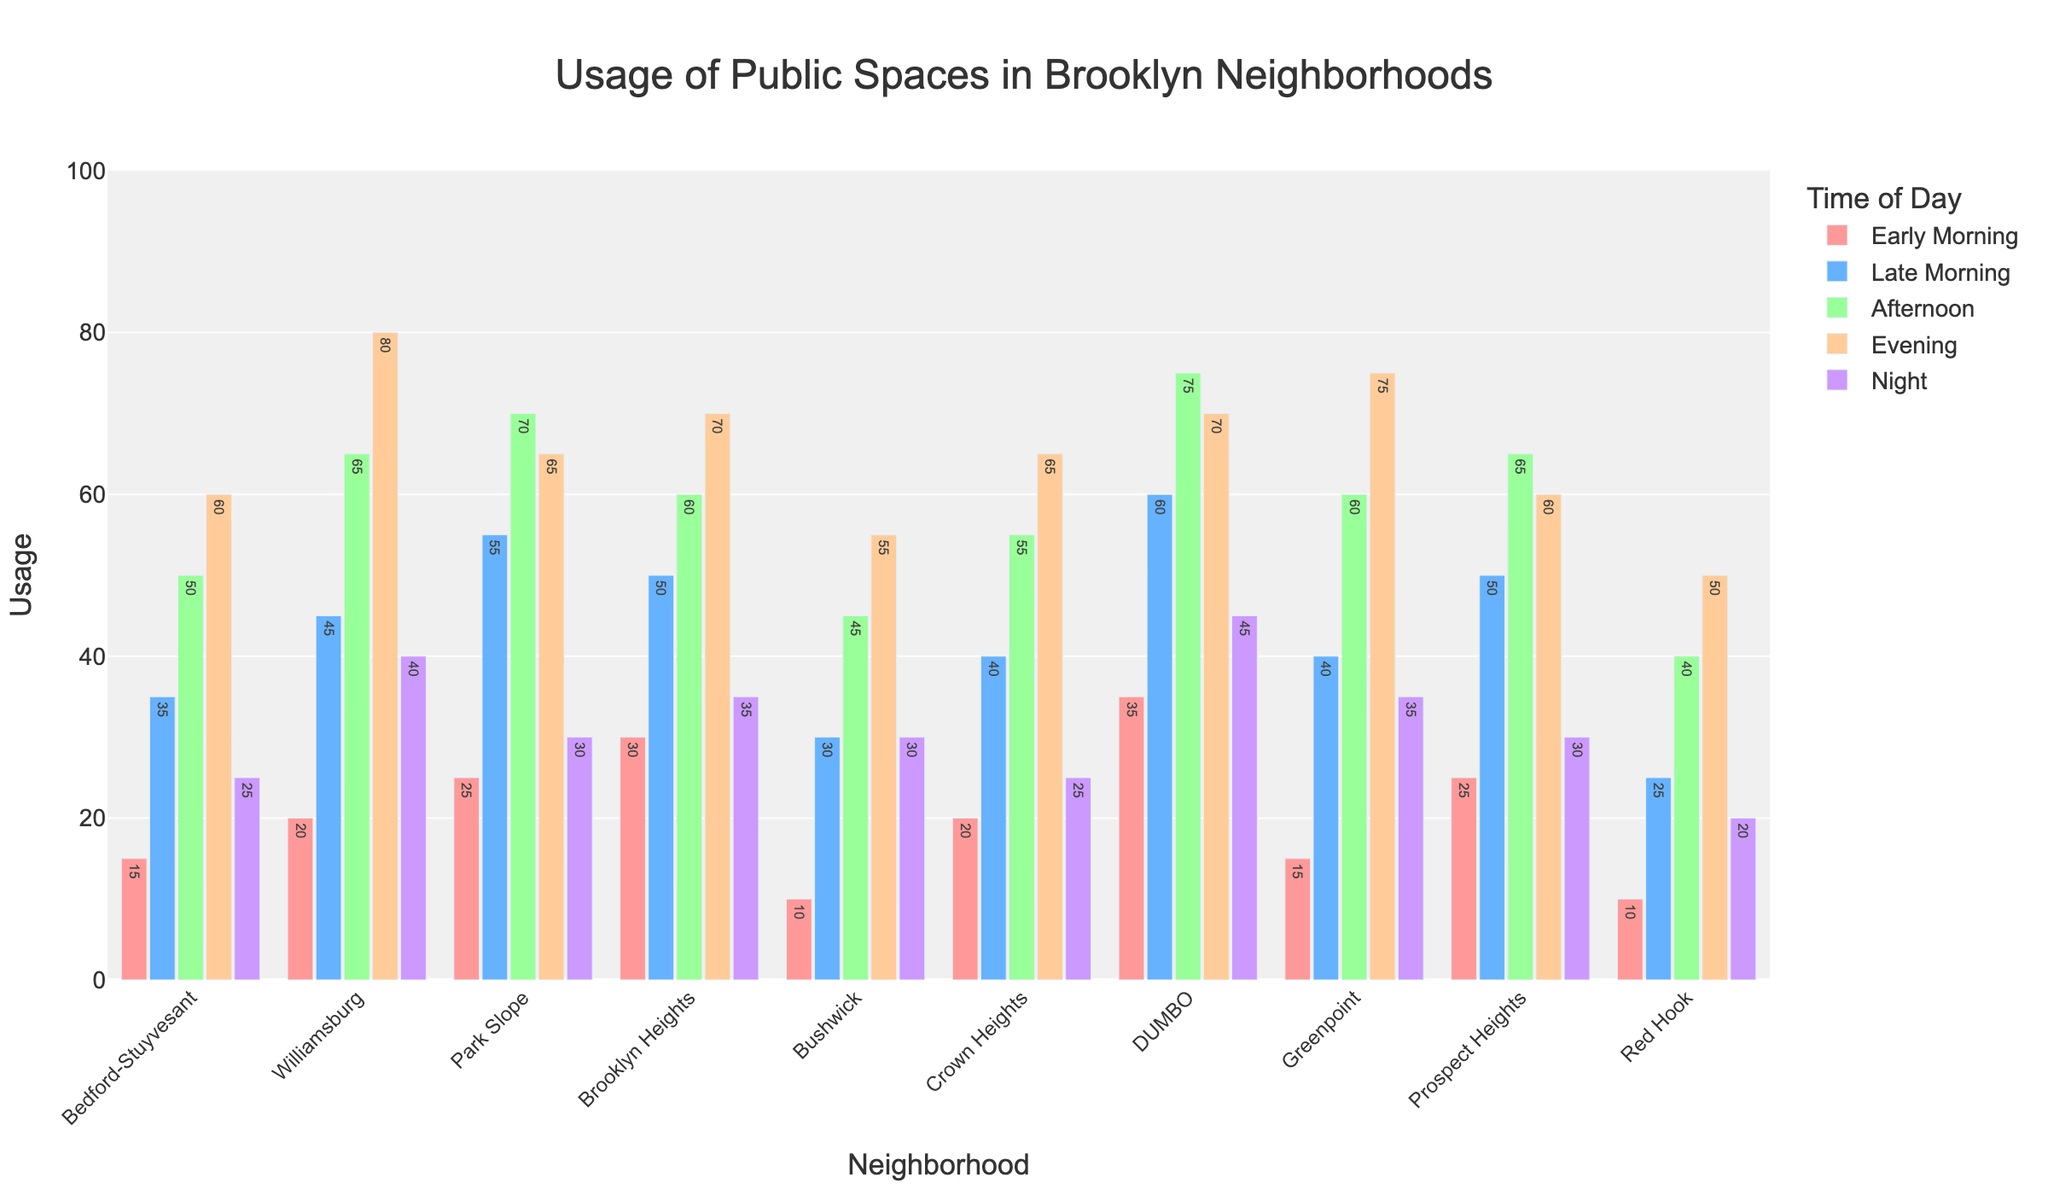Which neighborhood has the highest usage of public spaces in the early morning? To find the answer, look at the bar heights for "Early Morning" and identify the tallest one. The tallest bar in the "Early Morning" category belongs to DUMBO.
Answer: DUMBO Which time period has the highest usage in Williamsburg? For Williamsburg, compare the heights of all bars across different time periods. The Evening period has the highest bar, indicating the highest usage.
Answer: Evening Which neighborhood shows the least usage during the night? By comparing the heights of the Night bars for all neighborhoods, the shortest one is for Red Hook.
Answer: Red Hook What's the average usage of public spaces in Park Slope throughout the day? To calculate the average, add up all the usages in Park Slope and divide by the number of time periods: 25 + 55 + 70 + 65 + 30 = 245. Then, 245/5 = 49.
Answer: 49 Is the usage of public spaces in Crown Heights greater during the afternoon or the evening? Compare the heights of the bars for Afternoon and Evening in Crown Heights. The Evening bar is higher than the Afternoon bar.
Answer: Evening What is the total usage of public spaces in Brooklyn Heights and Bushwick during the late morning? Sum the heights of the Late Morning bars for both neighborhoods: 50 (Brooklyn Heights) + 30 (Bushwick) = 80.
Answer: 80 Which neighborhood has the smallest difference in usage between early morning and night? Calculate the absolute differences between Early Morning and Night usages for each neighborhood and find the smallest. Bedford-Stuyvesant: 10, Williamsburg: 20, Park Slope: 5, Brooklyn Heights: 5, Bushwick: 20, Crown Heights: 5, DUMBO: 10, Greenpoint: 20, Prospect Heights: 5, Red Hook: 10.
Answer: Park Slope, Brooklyn Heights, Crown Heights, Prospect Heights In which neighborhood is the usage during the afternoon closest to the usage during the evening? Calculate the absolute differences between Afternoon and Evening usages for each neighborhood and find the smallest: Bedford-Stuyvesant: 10, Williamsburg: 15, Park Slope: 5, Brooklyn Heights: 10, Bushwick: 10, Crown Heights: 10, DUMBO: 5, Greenpoint: 15, Prospect Heights: 5, Red Hook: 10.
Answer: Park Slope, DUMBO, Prospect Heights What is the maximum usage of public spaces recorded in any combination of time period and neighborhood? Look for the tallest bar across all time periods and neighborhoods. The tallest bar is in Williamsburg during the evening with a usage of 80.
Answer: 80 